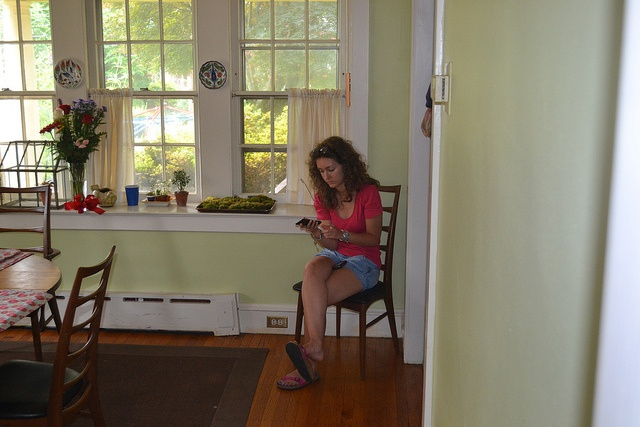Describe the objects in this image and their specific colors. I can see people in lightyellow, maroon, black, gray, and brown tones, chair in lightyellow, black, gray, and maroon tones, chair in lightyellow, black, gray, and maroon tones, chair in lightyellow, black, and gray tones, and potted plant in lightyellow, black, maroon, gray, and darkgreen tones in this image. 